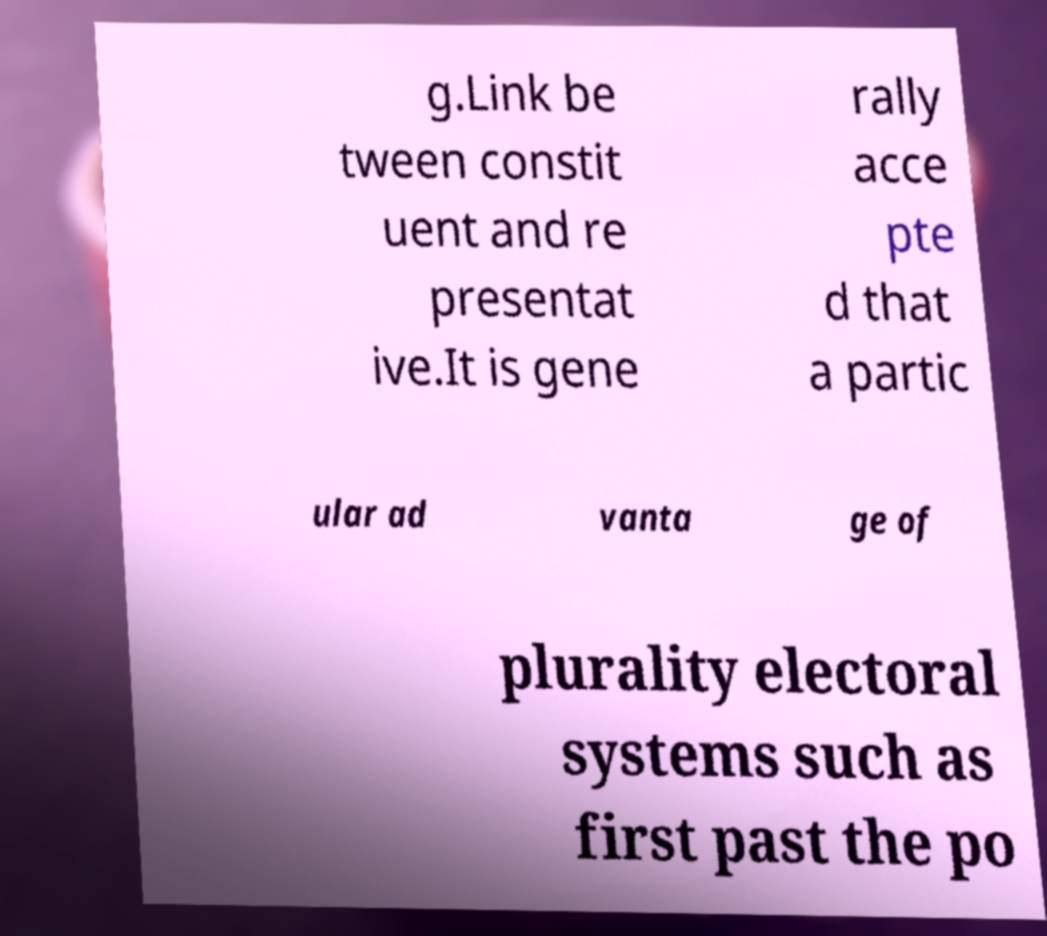There's text embedded in this image that I need extracted. Can you transcribe it verbatim? g.Link be tween constit uent and re presentat ive.It is gene rally acce pte d that a partic ular ad vanta ge of plurality electoral systems such as first past the po 